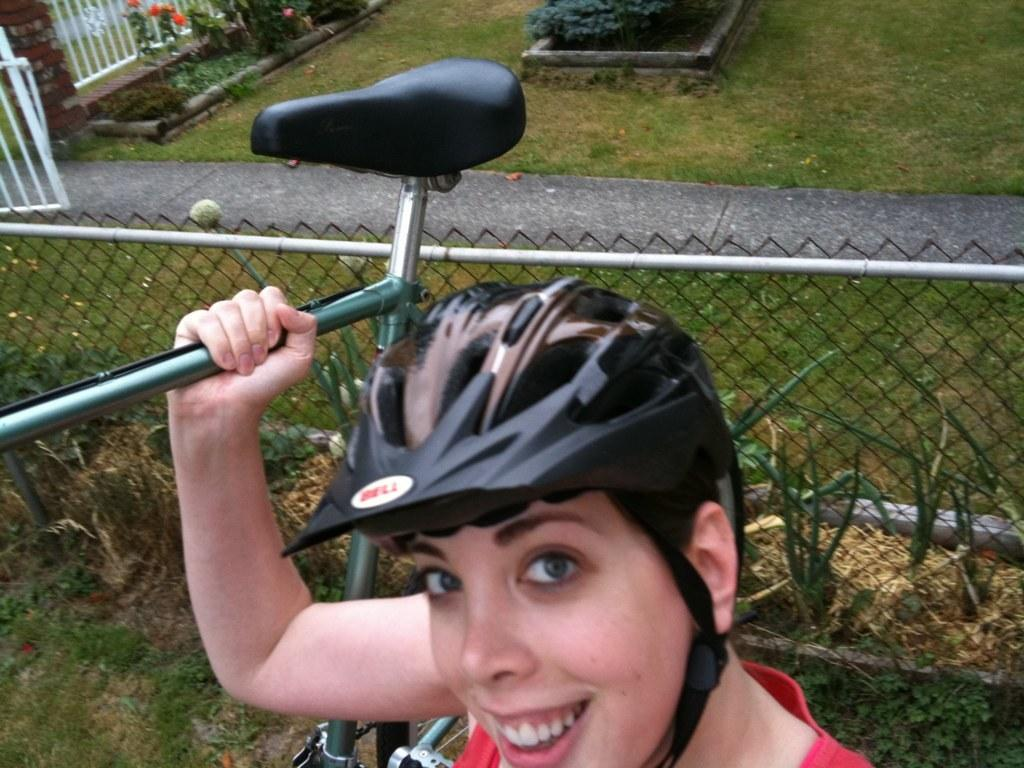Who is present in the image? There is a person in the image. What is the person doing in the image? The person is smiling and holding a bicycle. What can be seen in the background of the image? There is a fence, plants, flowers, and grass on the ground in the image. What type of oven can be seen in the image? There is no oven present in the image. What kind of coil is visible on the bicycle in the image? The image does not show any coils on the bicycle; it only shows the person holding the bicycle. 